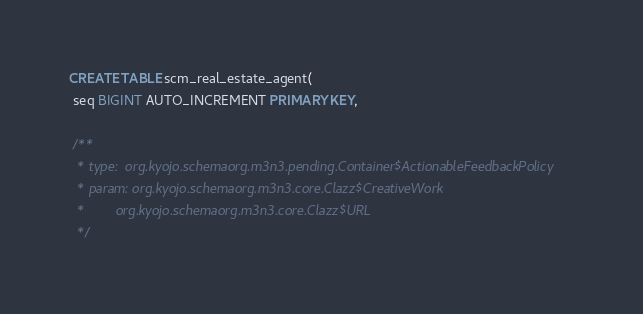<code> <loc_0><loc_0><loc_500><loc_500><_SQL_>CREATE TABLE scm_real_estate_agent(
 seq BIGINT AUTO_INCREMENT PRIMARY KEY,

 /**
  * type:  org.kyojo.schemaorg.m3n3.pending.Container$ActionableFeedbackPolicy
  * param: org.kyojo.schemaorg.m3n3.core.Clazz$CreativeWork
  *        org.kyojo.schemaorg.m3n3.core.Clazz$URL
  */</code> 